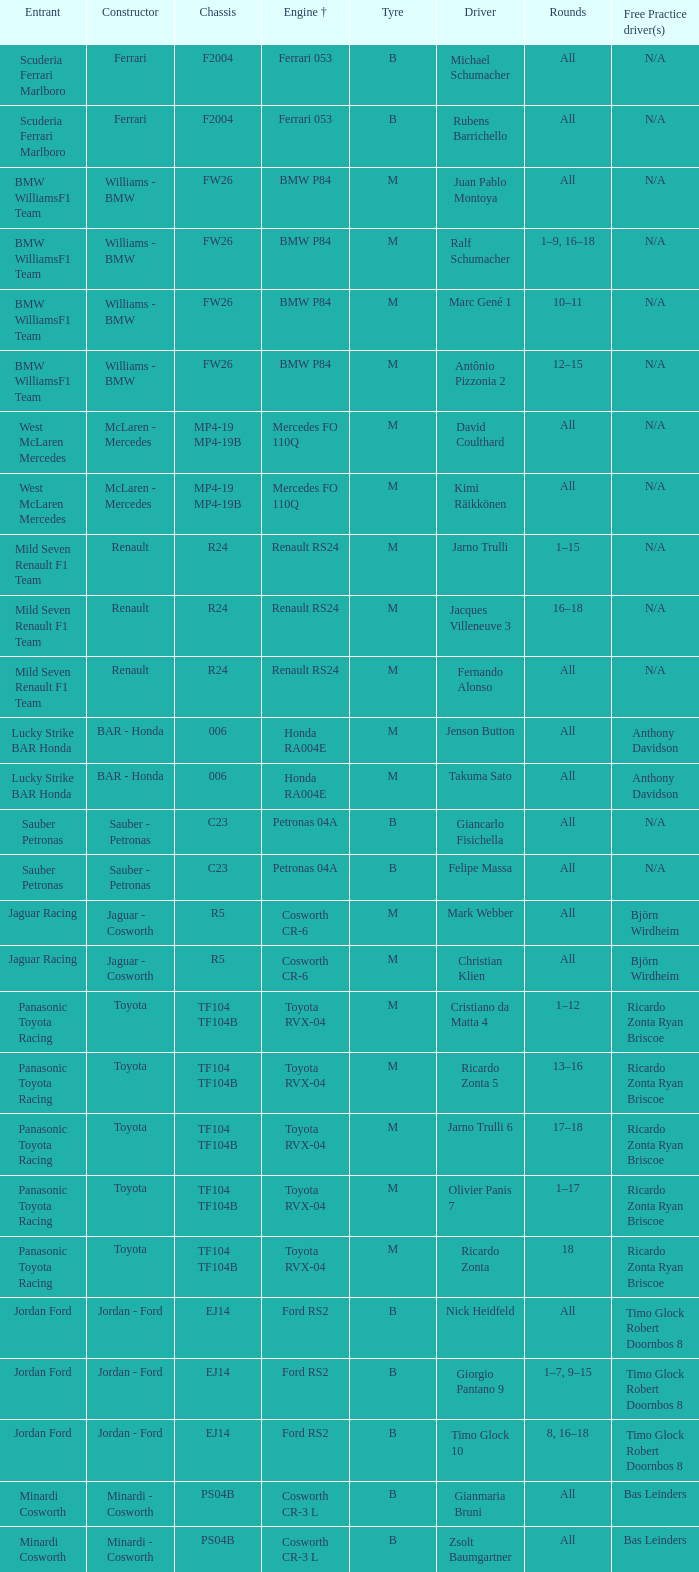What type of chassis is ricardo zonta equipped with? TF104 TF104B. 